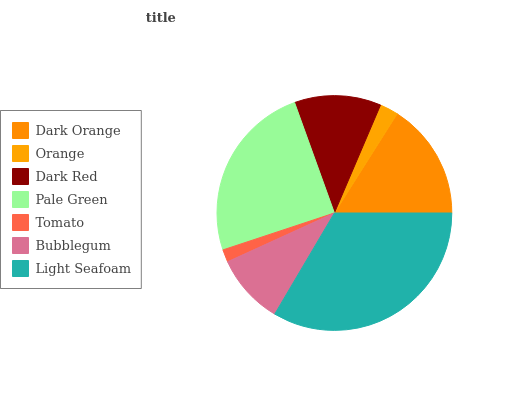Is Tomato the minimum?
Answer yes or no. Yes. Is Light Seafoam the maximum?
Answer yes or no. Yes. Is Orange the minimum?
Answer yes or no. No. Is Orange the maximum?
Answer yes or no. No. Is Dark Orange greater than Orange?
Answer yes or no. Yes. Is Orange less than Dark Orange?
Answer yes or no. Yes. Is Orange greater than Dark Orange?
Answer yes or no. No. Is Dark Orange less than Orange?
Answer yes or no. No. Is Dark Red the high median?
Answer yes or no. Yes. Is Dark Red the low median?
Answer yes or no. Yes. Is Pale Green the high median?
Answer yes or no. No. Is Light Seafoam the low median?
Answer yes or no. No. 